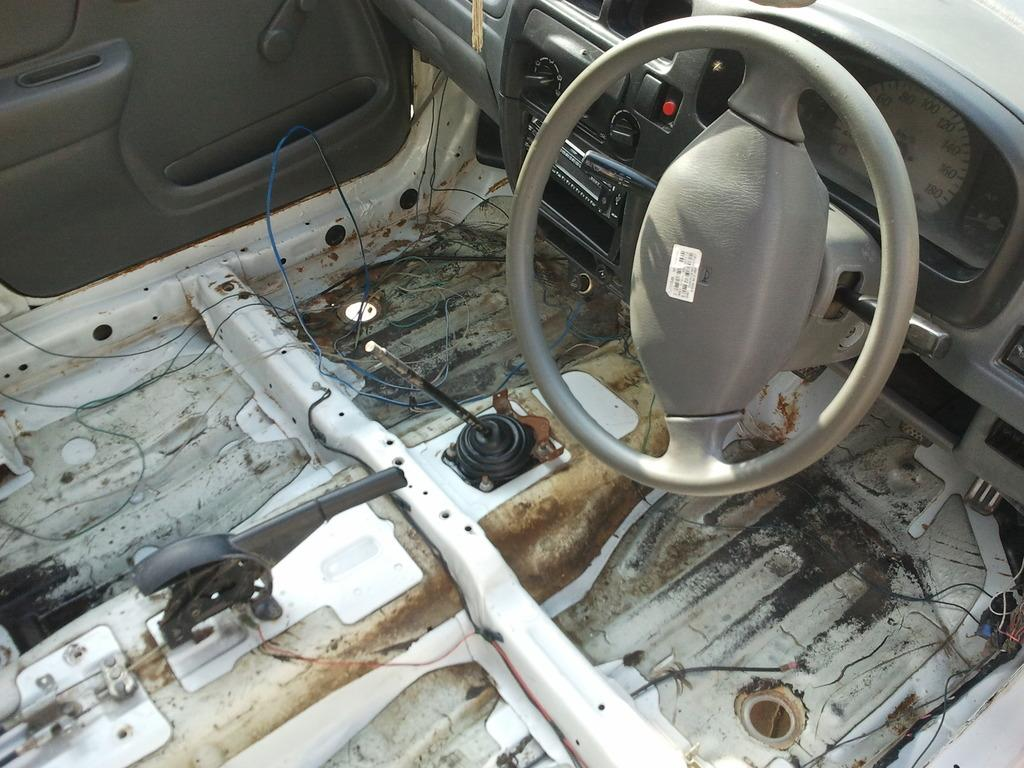What type of space is shown in the image? The image shows the interior of a vehicle. What part of the vehicle can be seen in the image? The dashboard is visible in the image. What feature is present for entertainment purposes? A music system is present in the image. What is used for steering the vehicle? The steering wheel is visible in the image. What part of the vehicle allows passengers to enter and exit? A door is present in the image. Are there any other objects visible in the image? Yes, there are additional objects in the image. Where is the baby being lifted by a crook in the image? There is no baby, lift, or crook present in the image. 